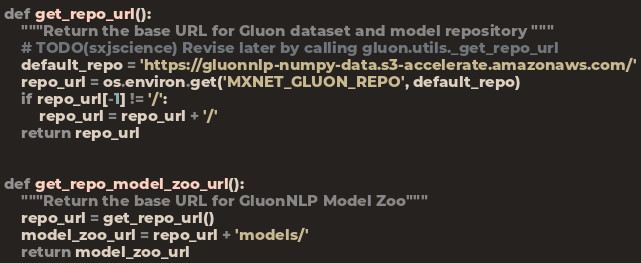Convert code to text. <code><loc_0><loc_0><loc_500><loc_500><_Python_>def get_repo_url():
    """Return the base URL for Gluon dataset and model repository """
    # TODO(sxjscience) Revise later by calling gluon.utils._get_repo_url
    default_repo = 'https://gluonnlp-numpy-data.s3-accelerate.amazonaws.com/'
    repo_url = os.environ.get('MXNET_GLUON_REPO', default_repo)
    if repo_url[-1] != '/':
        repo_url = repo_url + '/'
    return repo_url


def get_repo_model_zoo_url():
    """Return the base URL for GluonNLP Model Zoo"""
    repo_url = get_repo_url()
    model_zoo_url = repo_url + 'models/'
    return model_zoo_url
</code> 